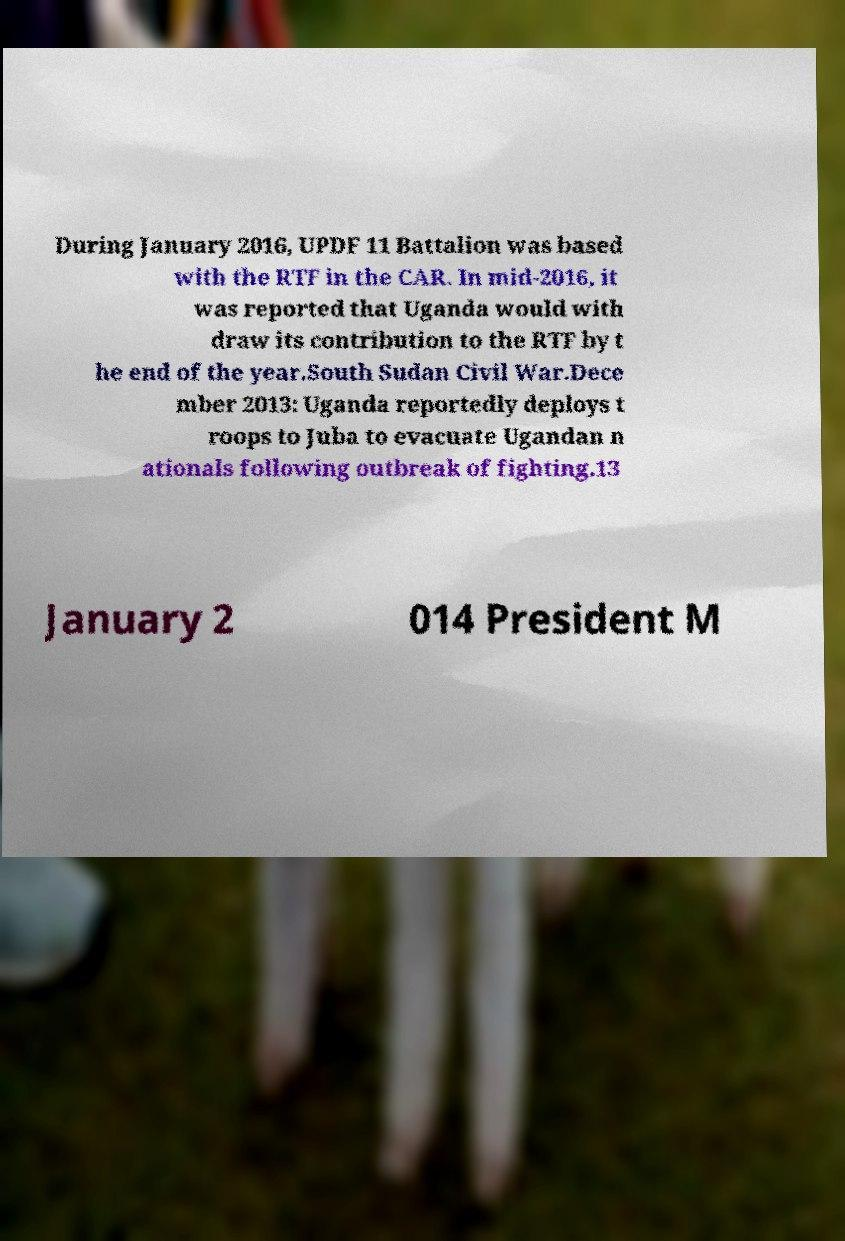Could you extract and type out the text from this image? During January 2016, UPDF 11 Battalion was based with the RTF in the CAR. In mid-2016, it was reported that Uganda would with draw its contribution to the RTF by t he end of the year.South Sudan Civil War.Dece mber 2013: Uganda reportedly deploys t roops to Juba to evacuate Ugandan n ationals following outbreak of fighting.13 January 2 014 President M 